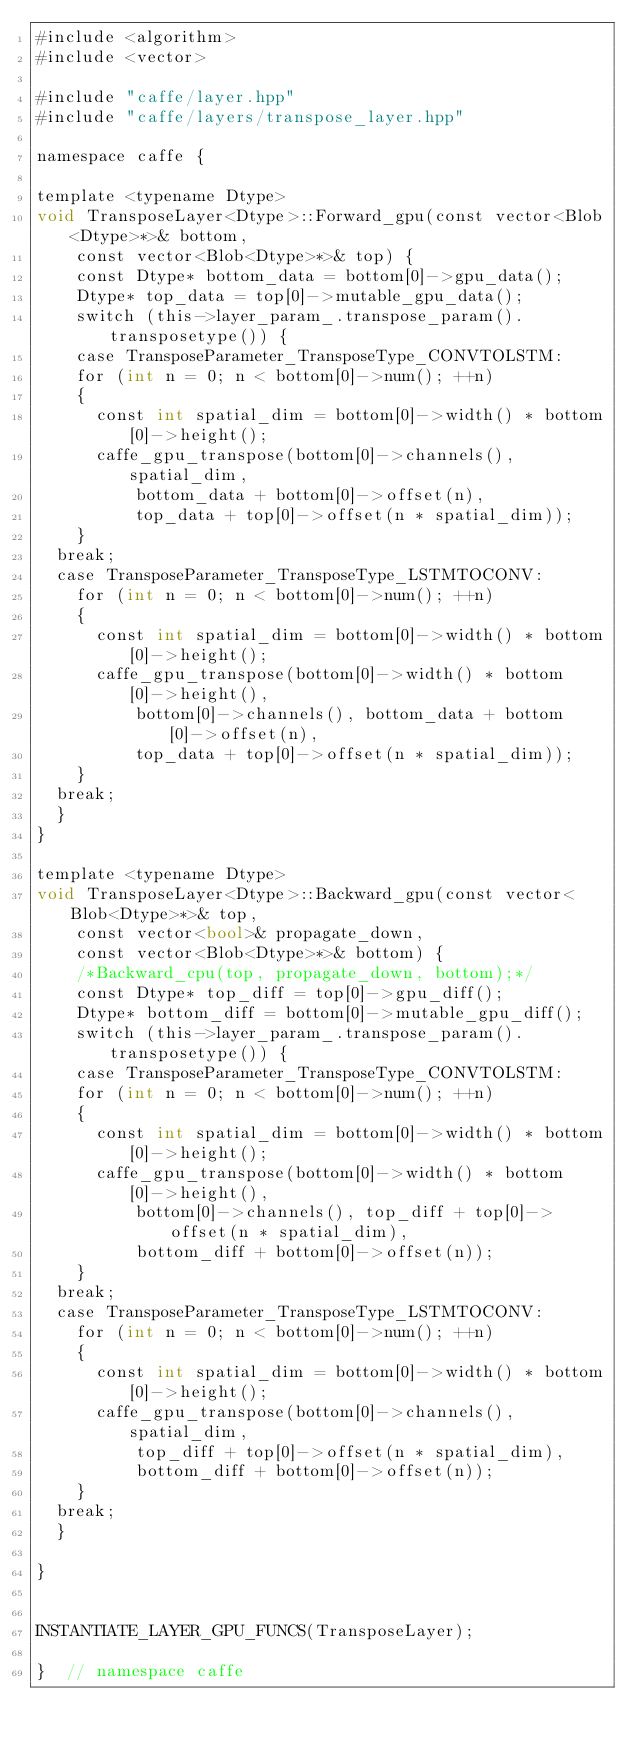<code> <loc_0><loc_0><loc_500><loc_500><_Cuda_>#include <algorithm>
#include <vector>

#include "caffe/layer.hpp"
#include "caffe/layers/transpose_layer.hpp"

namespace caffe {

template <typename Dtype>
void TransposeLayer<Dtype>::Forward_gpu(const vector<Blob<Dtype>*>& bottom,
    const vector<Blob<Dtype>*>& top) {
  	const Dtype* bottom_data = bottom[0]->gpu_data();
  	Dtype* top_data = top[0]->mutable_gpu_data();
  	switch (this->layer_param_.transpose_param().transposetype()) {
    case TransposeParameter_TransposeType_CONVTOLSTM:
		for (int n = 0; n < bottom[0]->num(); ++n) 
		{
			const int spatial_dim = bottom[0]->width() * bottom[0]->height();
			caffe_gpu_transpose(bottom[0]->channels(), spatial_dim,
			    bottom_data + bottom[0]->offset(n),
			    top_data + top[0]->offset(n * spatial_dim));
		}
	break;
	case TransposeParameter_TransposeType_LSTMTOCONV:
		for (int n = 0; n < bottom[0]->num(); ++n) 
		{
			const int spatial_dim = bottom[0]->width() * bottom[0]->height();
			caffe_gpu_transpose(bottom[0]->width() * bottom[0]->height(),
			    bottom[0]->channels(), bottom_data + bottom[0]->offset(n),
			    top_data + top[0]->offset(n * spatial_dim));
		}	
	break;
	}	
}

template <typename Dtype>
void TransposeLayer<Dtype>::Backward_gpu(const vector<Blob<Dtype>*>& top,
    const vector<bool>& propagate_down,
    const vector<Blob<Dtype>*>& bottom) {
  	/*Backward_cpu(top, propagate_down, bottom);*/
  	const Dtype* top_diff = top[0]->gpu_diff();
  	Dtype* bottom_diff = bottom[0]->mutable_gpu_diff();
  	switch (this->layer_param_.transpose_param().transposetype()) {
    case TransposeParameter_TransposeType_CONVTOLSTM:
		for (int n = 0; n < bottom[0]->num(); ++n) 
		{
			const int spatial_dim = bottom[0]->width() * bottom[0]->height();
			caffe_gpu_transpose(bottom[0]->width() * bottom[0]->height(),
			    bottom[0]->channels(), top_diff + top[0]->offset(n * spatial_dim),
			    bottom_diff + bottom[0]->offset(n));
		}
	break;
	case TransposeParameter_TransposeType_LSTMTOCONV:
		for (int n = 0; n < bottom[0]->num(); ++n) 
		{
			const int spatial_dim = bottom[0]->width() * bottom[0]->height();
			caffe_gpu_transpose(bottom[0]->channels(), spatial_dim,			    
			    top_diff + top[0]->offset(n * spatial_dim),
			    bottom_diff + bottom[0]->offset(n));
		}
	break;
	}		

}


INSTANTIATE_LAYER_GPU_FUNCS(TransposeLayer);

}  // namespace caffe
</code> 